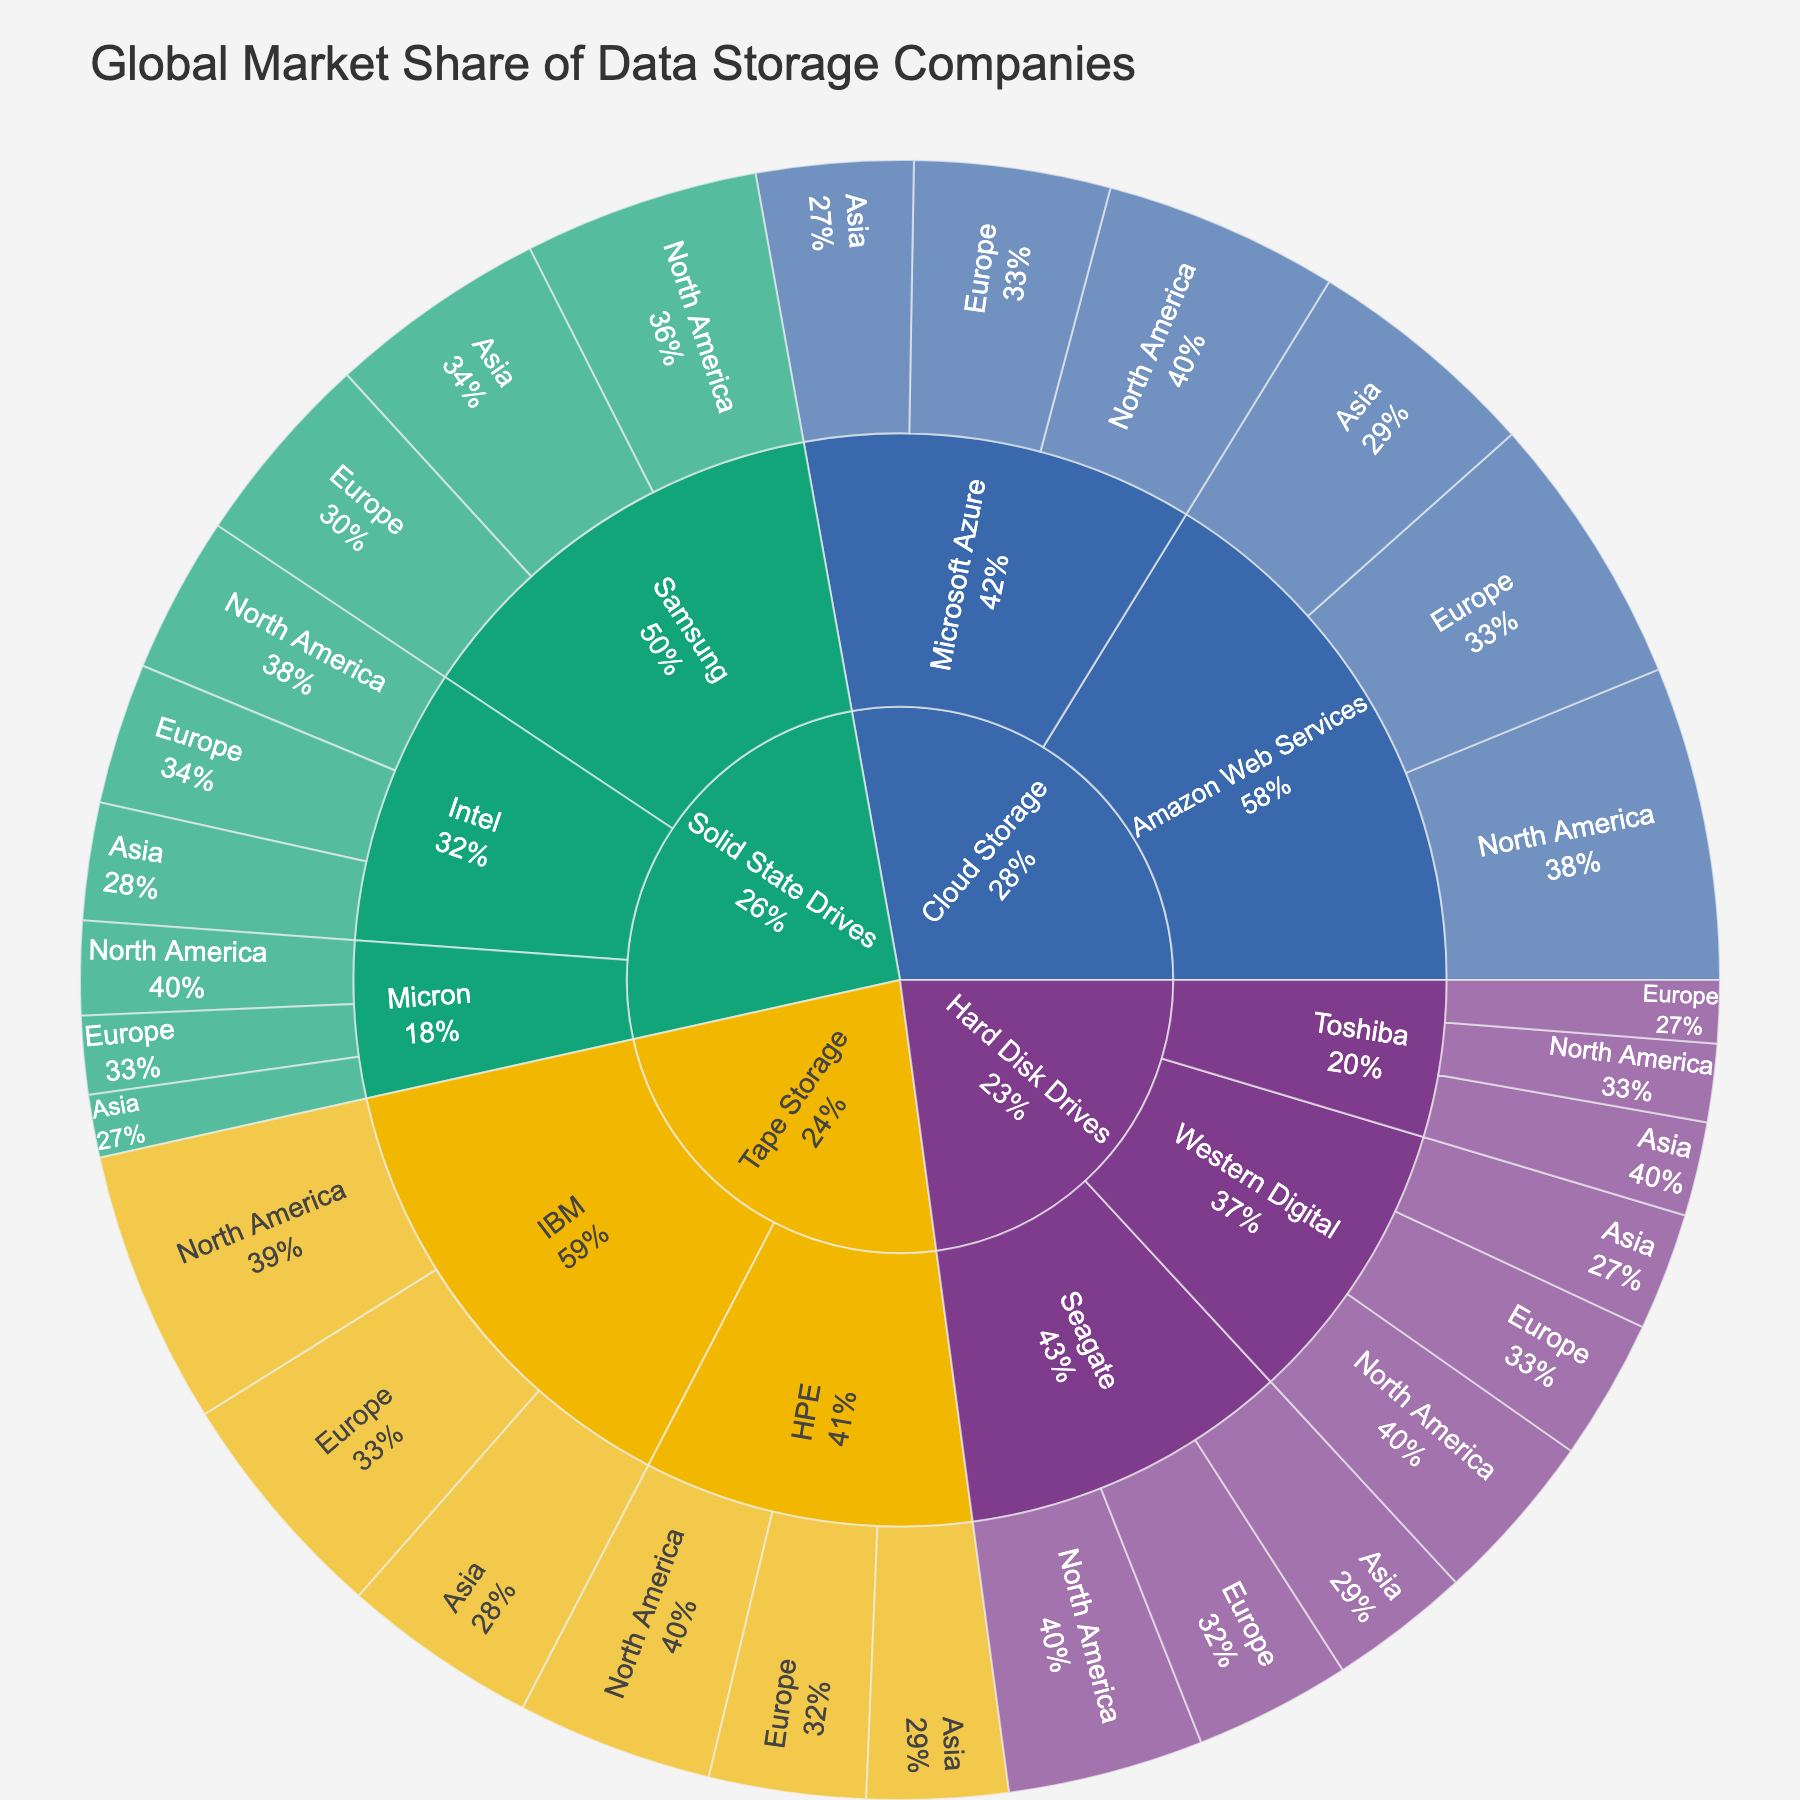What is the total market share for Hard Disk Drives in North America? To find the total market share for Hard Disk Drives in North America, add up the values for Seagate (25), Western Digital (22), and Toshiba (10). 25 + 22 + 10 = 57
Answer: 57 Which company has the highest market share in Europe for Solid State Drives? Look within the Solid State Drives category for Europe; compare the values of Samsung (25), Intel (18), and Micron (10). Samsung has the highest market share.
Answer: Samsung How does IBM's market share in Asia for Tape Storage compare to HPE's share in the same region? IBM's market share in Asia is 25, and HPE's share is 18 for Tape Storage. Compare the two values: IBM's share (25) is greater than HPE's (18).
Answer: IBM's share is greater What is the total market share for Cloud Storage in Europe? To get the total market share for Cloud Storage in Europe, add up the values for Amazon Web Services (35) and Microsoft Azure (25). 35 + 25 = 60
Answer: 60 Which product line has the lowest market share in Asia? Compare the market shares for each product line in Asia: Hard Disk Drives (Seagate: 18, Western Digital: 15, Toshiba: 12), Solid State Drives (Samsung: 28, Intel: 15, Micron: 8), Tape Storage (IBM: 25, HPE: 18), and Cloud Storage (Amazon Web Services: 30, Microsoft Azure: 20). Micron for Solid State Drives has the lowest share with 8.
Answer: Solid State Drives, Micron How does the market share of Samsung in North America for Solid State Drives compare to Seagate in North America for Hard Disk Drives? Samsung's market share in North America for Solid State Drives is 30, and Seagate's share for Hard Disk Drives is 25. Compare the two values: Samsung's share (30) is larger than Seagate's (25).
Answer: Samsung's share is larger What is the total market share for all data storage companies in North America? Sum the market shares for all categories and subcategories in North America. Hard Disk Drives (Seagate: 25, Western Digital: 22, Toshiba: 10), Solid State Drives (Samsung: 30, Intel: 20, Micron: 12), Tape Storage (IBM: 35, HPE: 25), and Cloud Storage (Amazon Web Services: 40, Microsoft Azure: 30). 25 + 22 + 10 + 30 + 20 + 12 + 35 + 25 + 40 + 30 = 249
Answer: 249 Which region has the highest total market share for Solid State Drives? Compare the total market shares for Solid State Drives in North America (Samsung: 30, Intel: 20, Micron: 12), Europe (Samsung: 25, Intel: 18, Micron: 10), and Asia (Samsung: 28, Intel: 15, Micron: 8). North America has the highest total with 30 + 20 + 12 = 62.
Answer: North America What percentage of the global market does IBM hold for Tape Storage? Total market share for Tape Storage is IBM's sum (North America: 35, Europe: 30, Asia: 25) and HPE's sum (North America: 25, Europe: 20, Asia: 18). Calculate the total: 35 + 30 + 25 + 25 + 20 + 18 = 153. IBM's total is 35 + 30 + 25 = 90. Percentage: (90/153) * 100 ≈ 58.82%
Answer: 58.82% What is the difference in market share between Amazon Web Services and Microsoft Azure in Asia for Cloud Storage? In Asia, the market share for Amazon Web Services is 30 and for Microsoft Azure is 20. Calculate the difference: 30 - 20 = 10
Answer: 10 